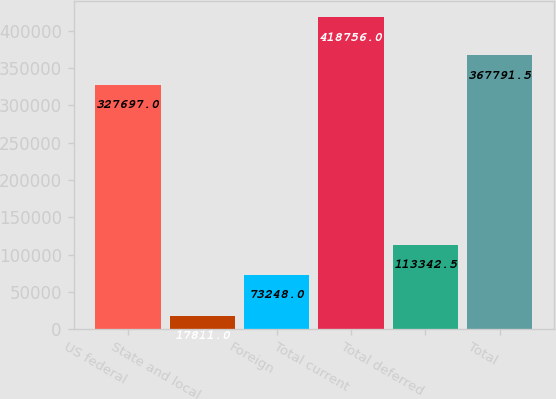Convert chart. <chart><loc_0><loc_0><loc_500><loc_500><bar_chart><fcel>US federal<fcel>State and local<fcel>Foreign<fcel>Total current<fcel>Total deferred<fcel>Total<nl><fcel>327697<fcel>17811<fcel>73248<fcel>418756<fcel>113342<fcel>367792<nl></chart> 